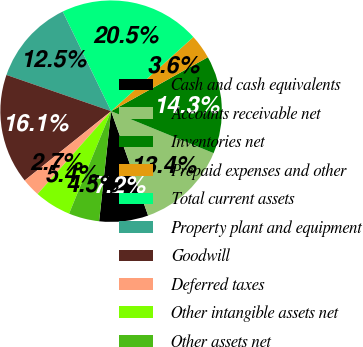Convert chart. <chart><loc_0><loc_0><loc_500><loc_500><pie_chart><fcel>Cash and cash equivalents<fcel>Accounts receivable net<fcel>Inventories net<fcel>Prepaid expenses and other<fcel>Total current assets<fcel>Property plant and equipment<fcel>Goodwill<fcel>Deferred taxes<fcel>Other intangible assets net<fcel>Other assets net<nl><fcel>7.15%<fcel>13.39%<fcel>14.28%<fcel>3.58%<fcel>20.52%<fcel>12.5%<fcel>16.06%<fcel>2.69%<fcel>5.36%<fcel>4.47%<nl></chart> 